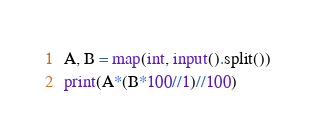<code> <loc_0><loc_0><loc_500><loc_500><_Python_>A, B = map(int, input().split())
print(A*(B*100//1)//100)</code> 